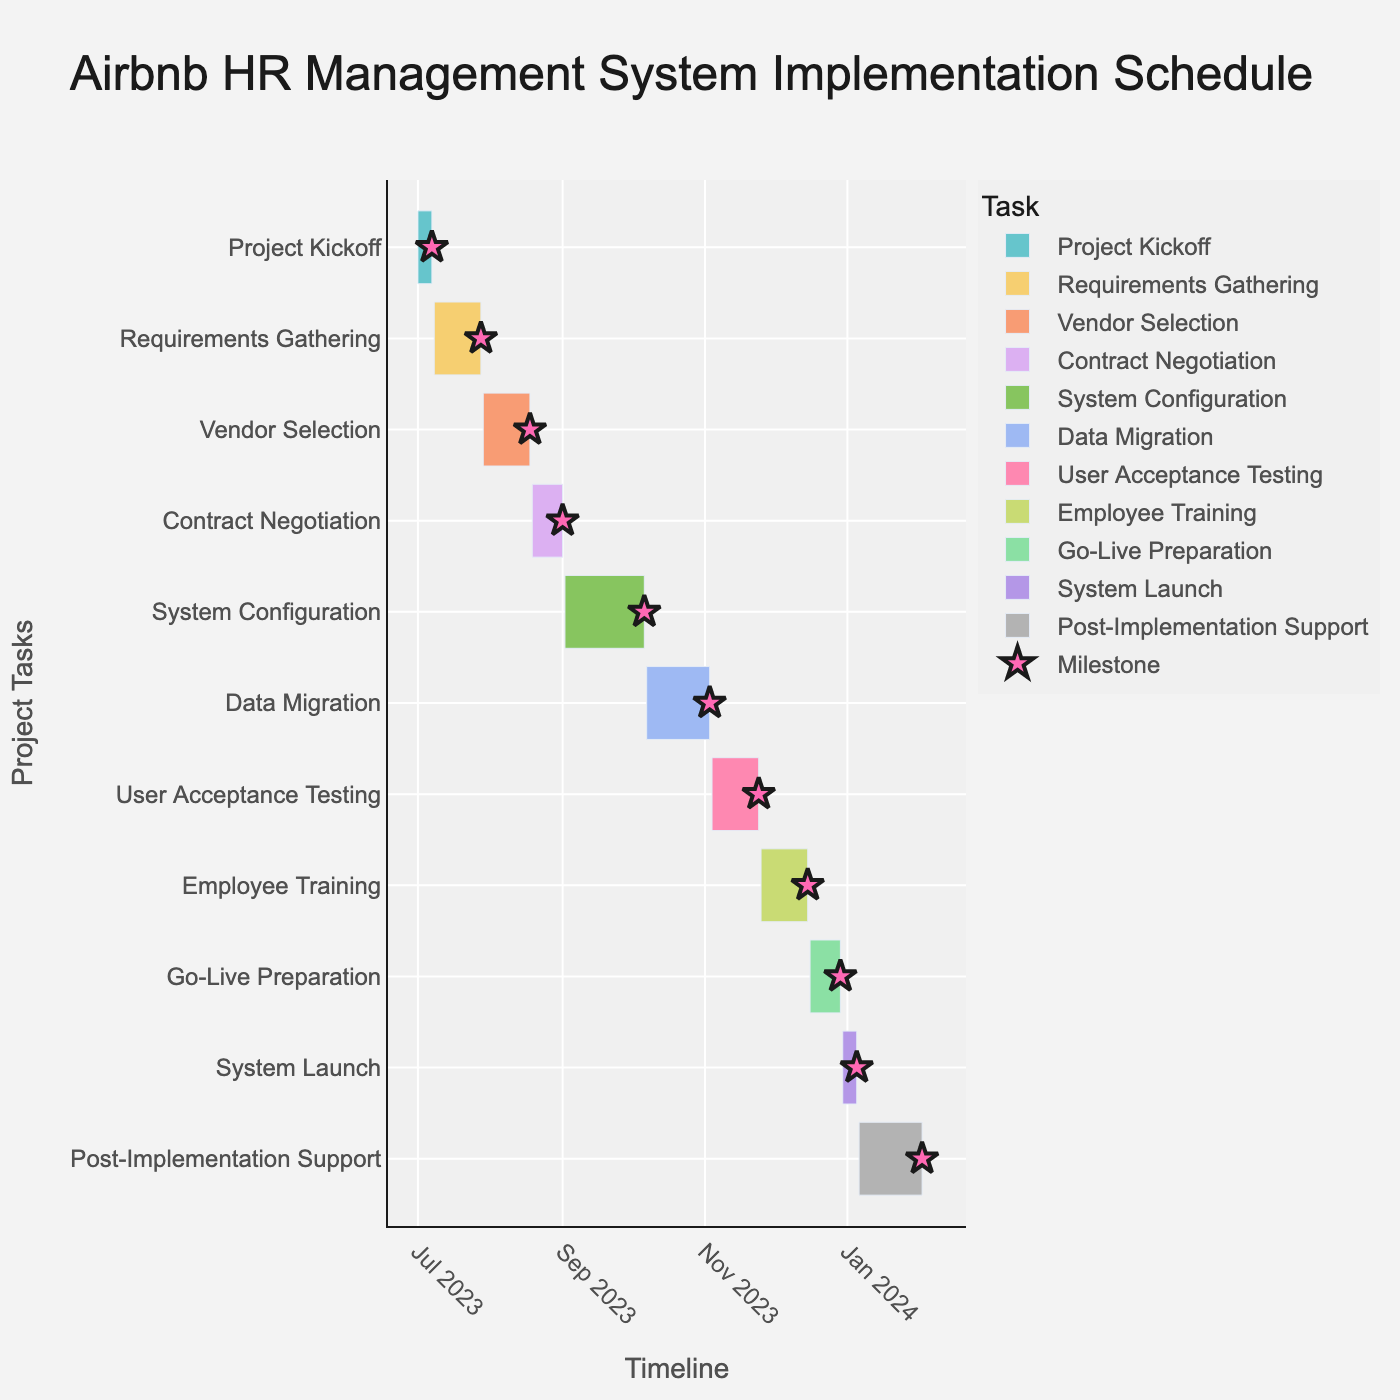What is the duration of the 'Data Migration' task? Locate the 'Data Migration' task on the y-axis and look to the hover information or reference the data, which shows the duration as 28 days.
Answer: 28 days When does the 'System Launch' occur? Find the 'System Launch' task on the y-axis and refer to the x-axis timeline or hover information to see it occurs from December 30, 2023, to January 5, 2024.
Answer: December 30, 2023, to January 5, 2024 How many tasks have a duration of 21 days? Count the tasks (by their hover information) that show a duration of 21 days, which include 'Requirements Gathering,' 'Vendor Selection,' 'User Acceptance Testing,' and 'Employee Training.'
Answer: 4 Which task has the longest duration, and what is that duration? Check the hover information for all tasks and find 'System Configuration' which has the longest duration of 35 days.
Answer: 'System Configuration' for 35 days What is the total duration of all tasks combined? Sum the individual durations from the hover information: 7 + 21 + 21 + 14 + 35 + 28 + 21 + 21 + 14 + 7 + 28 = 217 days.
Answer: 217 days Does the 'Requirements Gathering' task overlap with the 'Vendor Selection' task? Look at the timeline bars for both tasks; 'Requirements Gathering' ends on July 28, 2023, and 'Vendor Selection' starts on July 29, 2023, showing no overlap.
Answer: No Which two tasks take place just before and after the 'Employee Training'? Identify the task located just before ('User Acceptance Testing' ending on November 24, 2023) and just after ('Go-Live Preparation' starting on December 16, 2023) 'Employee Training' on the timeline.
Answer: 'User Acceptance Testing' and 'Go-Live Preparation' How long after the 'Project Kickoff' does the 'Data Migration' task begin? Calculate the days between the end date of 'Project Kickoff' (July 7, 2023) and the start date of 'Data Migration' (October 7, 2023), which spans three months (approximately 92 days).
Answer: 92 days What is the sequence of tasks during the month of October 2023? Review the timeline and identify 'System Configuration' (ends October 6, 2023) and 'Data Migration' (starts October 7, 2023 and ends November 3, 2023) occurring in October.
Answer: 'System Configuration' and 'Data Migration' 